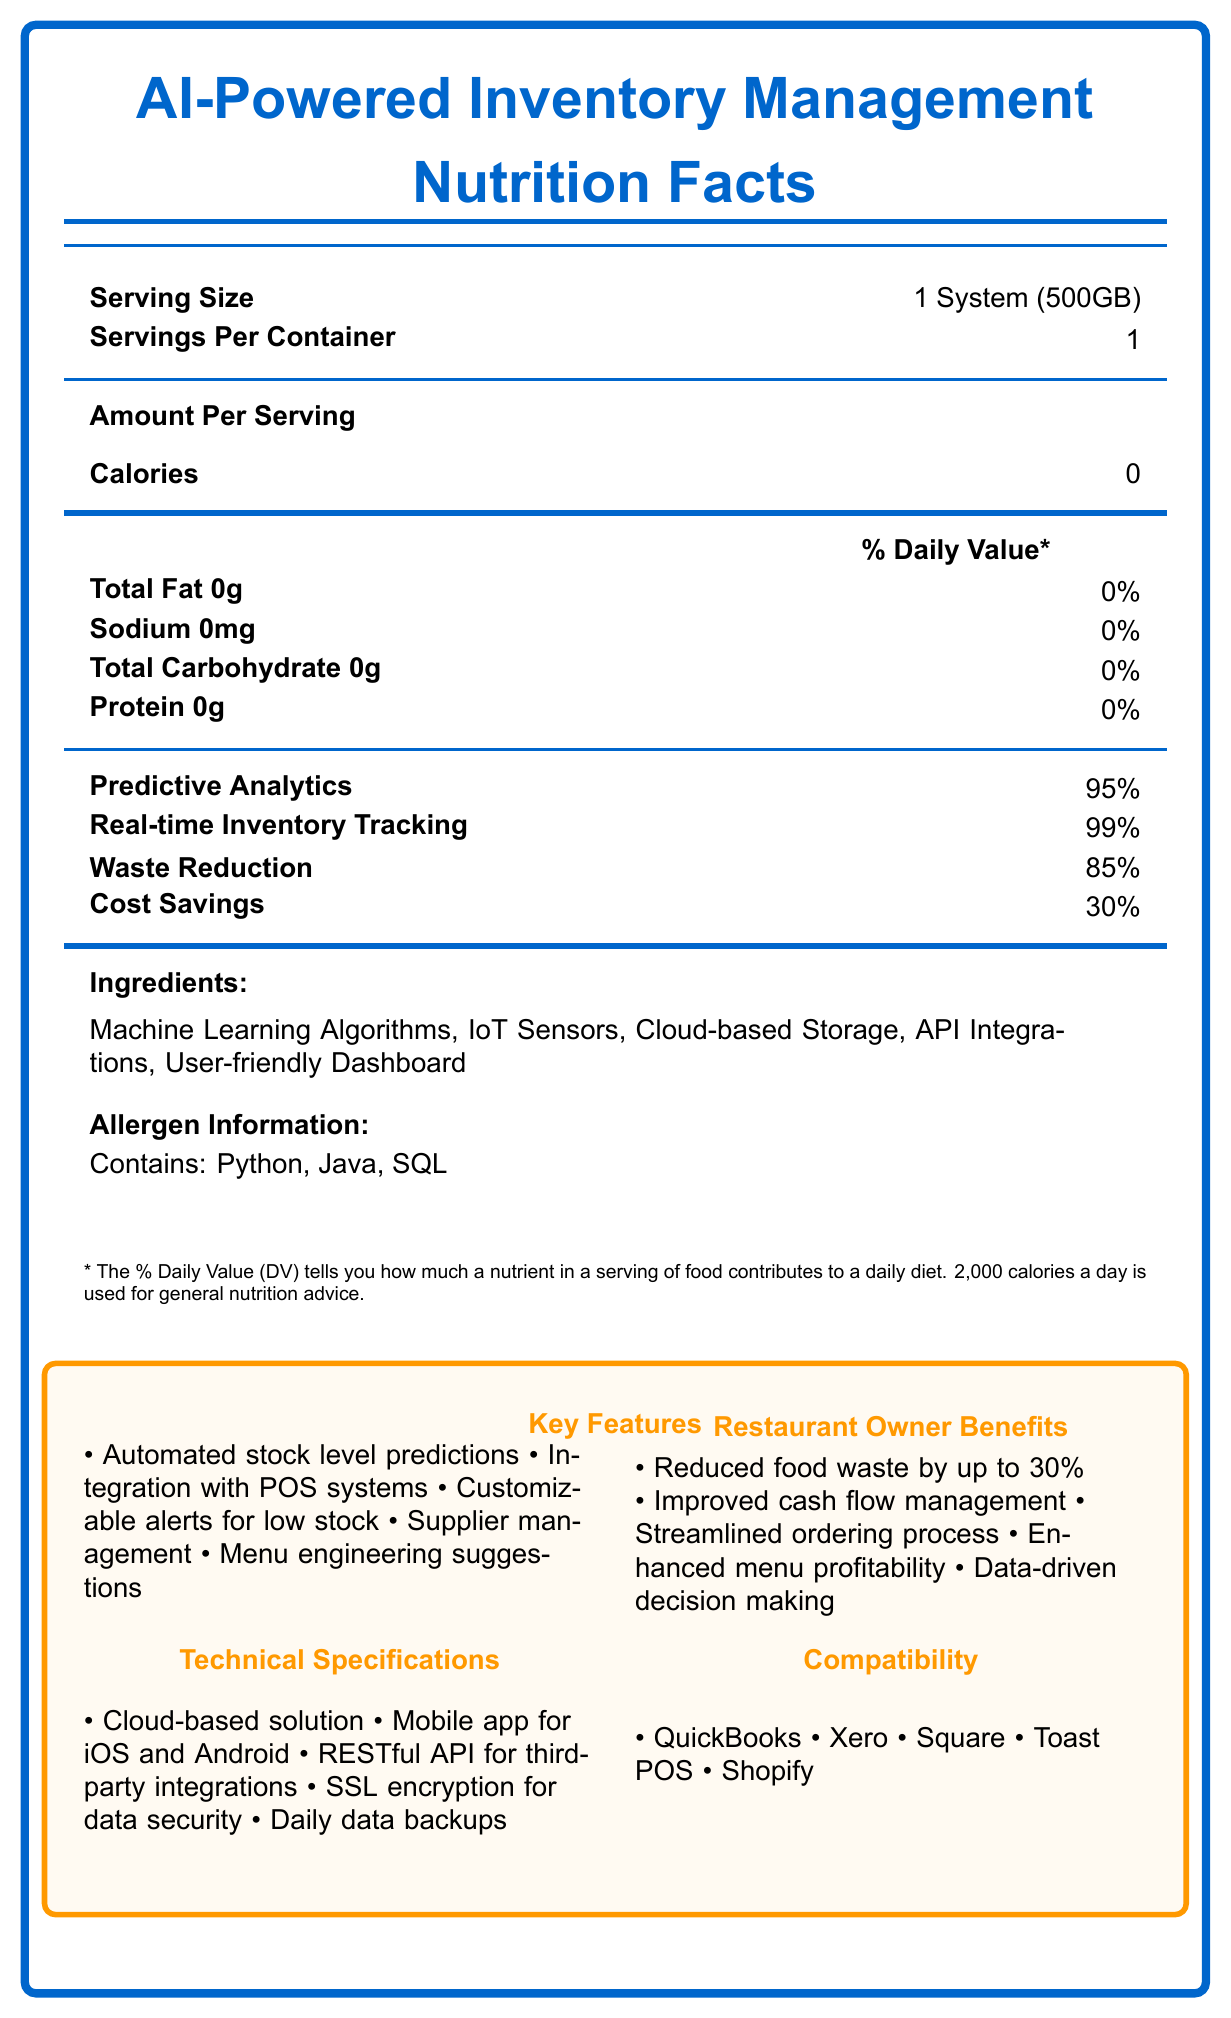what is the serving size? The document states the serving size as "1 System (500GB)".
Answer: 1 System (500GB) how many servings per container are there? The document specifies that there is 1 serving per container.
Answer: 1 what is the percentage value of Waste Reduction? The document lists Waste Reduction with a value of 85%.
Answer: 85% what are the main ingredients of the AI-Powered Inventory Management system? These components are listed under the "Ingredients" section of the document.
Answer: Machine Learning Algorithms, IoT Sensors, Cloud-based Storage, API Integrations, User-friendly Dashboard does the AI-powered system contain any calories? The document states that the system contains 0 calories.
Answer: No what software languages are mentioned in the allergen information? The allergen information section mentions these programming languages.
Answer: Python, Java, SQL what are the key features of the AI-powered inventory management system? These are listed in the "Key Features" section of the document.
Answer: Automated stock level predictions, Integration with POS systems, Customizable alerts for low stock, Supplier management, Menu engineering suggestions what percentage of the daily value does predictive analytics contribute? A. 90% B. 85% C. 95% D. 100% Predictive Analytics is listed as contributing 95%.
Answer: C. 95% which of the following is a benefit for restaurant owners using the AI-powered system? A. Increased marketing exposure B. Reduced food waste C. Extended warranties D. Free trial period The "Restaurant Owner Benefits" section lists "Reduced food waste by up to 30%" as a benefit.
Answer: B. Reduced food waste is the AI-powered system cloud-based? The "Technical Specifications" section notes that it is a "Cloud-based solution".
Answer: Yes is "Cost Savings" at 85% of its daily value? The document lists Cost Savings at 30% value.
Answer: No describe the main idea of the document. The document outlines various features, benefits, and technical specifications of an AI-powered inventory management system designed to help restaurant owners manage stock levels and reduce waste effectively.
Answer: The document is a Nutrition Facts style label for an AI-powered inventory management system, providing details on the system's serving size, ingredients, predictive analytics, and benefits for restaurant owners. It highlights key features such as real-time inventory tracking and waste reduction, along with technical specifications and compatibility with other systems. what is the exact cloud storage provider used for the AI-powered inventory management system? The document mentions "Cloud-based Storage" as an ingredient but does not specify the exact cloud storage provider.
Answer: I don't know 